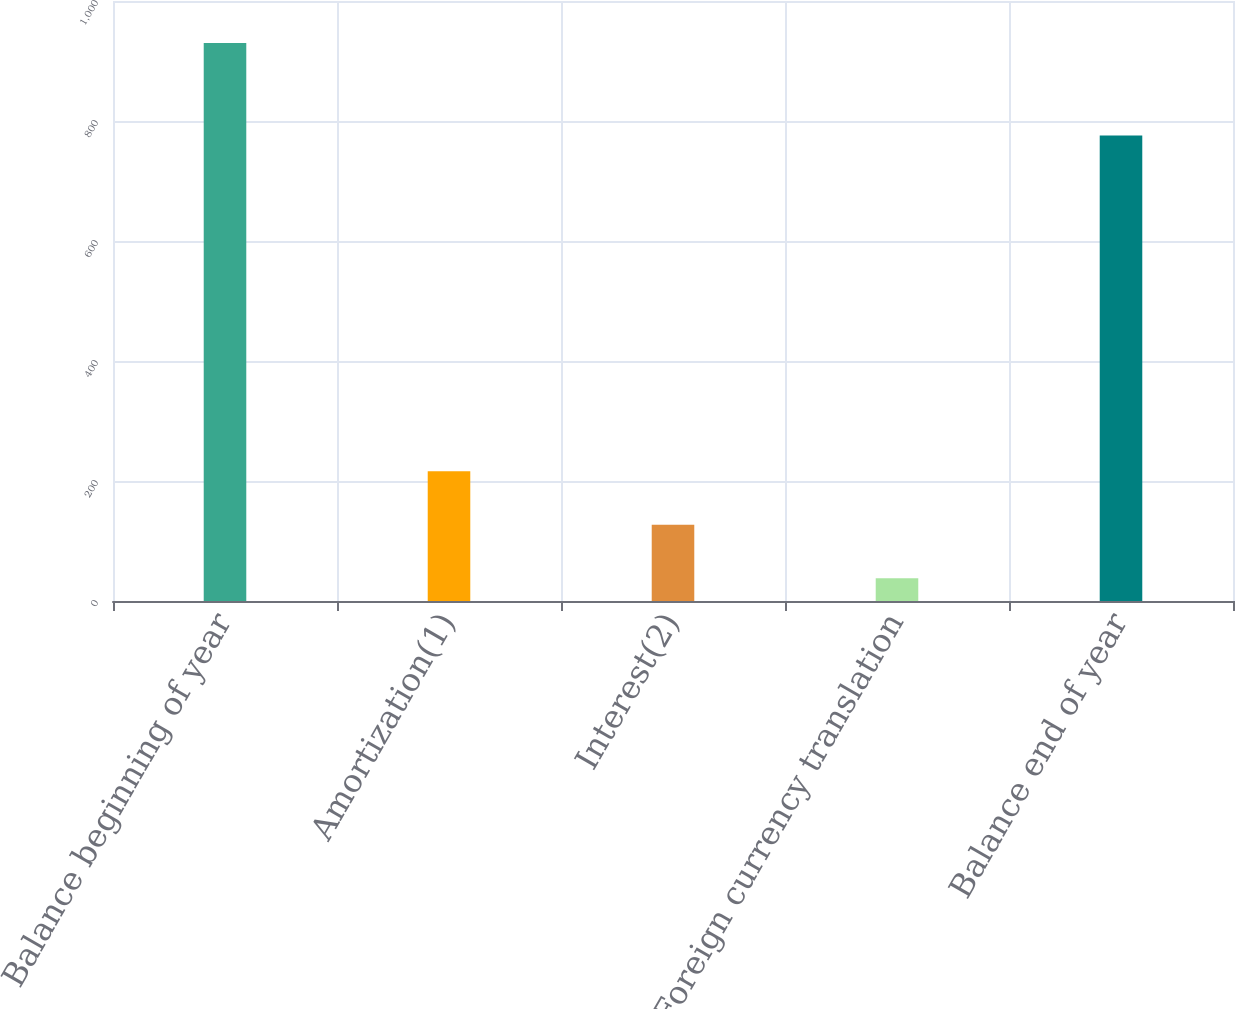Convert chart to OTSL. <chart><loc_0><loc_0><loc_500><loc_500><bar_chart><fcel>Balance beginning of year<fcel>Amortization(1)<fcel>Interest(2)<fcel>Foreign currency translation<fcel>Balance end of year<nl><fcel>930<fcel>216.4<fcel>127.2<fcel>38<fcel>776<nl></chart> 